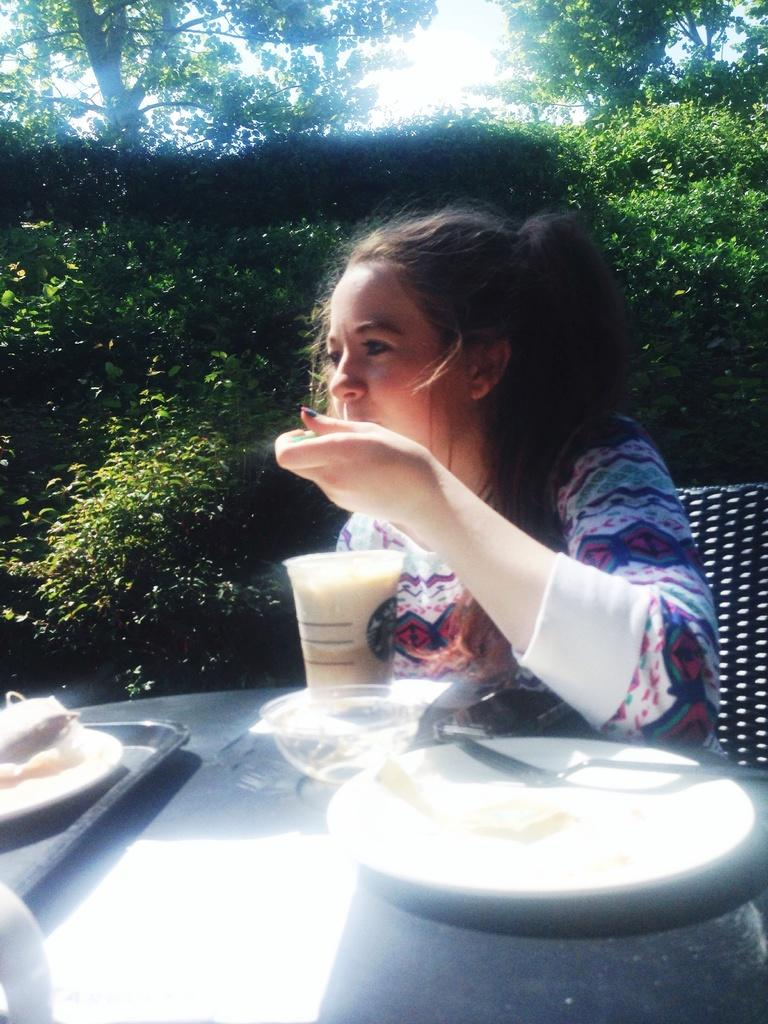What is the woman doing in the image? The woman is sitting on a chair in the image. What is the woman holding in the image? The woman is holding an object in the image. What can be seen on the table in the image? There are plates and a tray on the table in the image. What is visible in the background of the image? Trees, plants, and the sky are visible in the background of the image. What songs is the woman singing in the image? There is no indication in the image that the woman is singing any songs. 